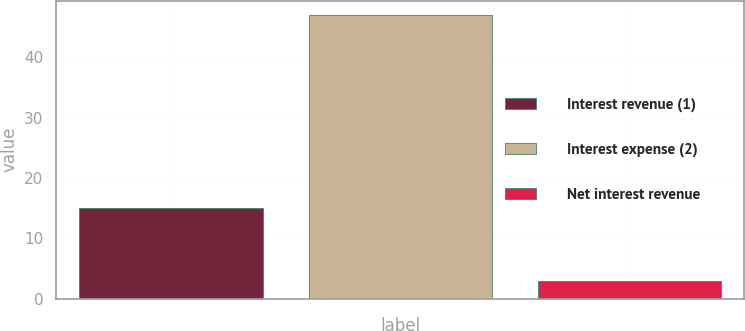Convert chart. <chart><loc_0><loc_0><loc_500><loc_500><bar_chart><fcel>Interest revenue (1)<fcel>Interest expense (2)<fcel>Net interest revenue<nl><fcel>15<fcel>47<fcel>3<nl></chart> 